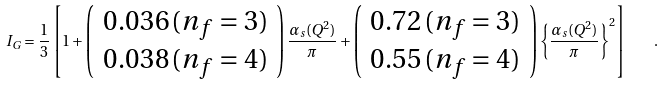<formula> <loc_0><loc_0><loc_500><loc_500>I _ { G } = \frac { 1 } { 3 } \left [ 1 + \left ( \begin{array} { l } { { 0 . 0 3 6 \, ( n _ { f } = 3 ) } } \\ { { 0 . 0 3 8 \, ( n _ { f } = 4 ) } } \end{array} \right ) \frac { \alpha _ { s } ( Q ^ { 2 } ) } { \pi } + \left ( \begin{array} { l } { { 0 . 7 2 \, ( n _ { f } = 3 ) } } \\ { { 0 . 5 5 \, ( n _ { f } = 4 ) } } \end{array} \right ) \left \{ \frac { \alpha _ { s } ( Q ^ { 2 } ) } { \pi } \right \} ^ { 2 } \right ] \quad .</formula> 